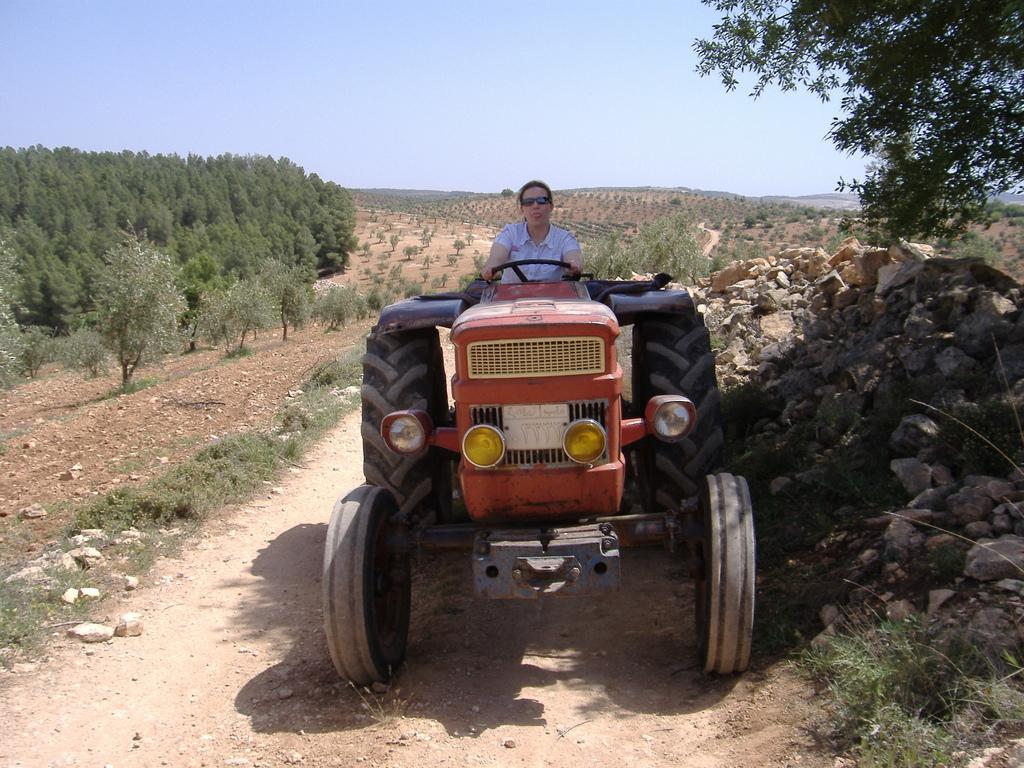Please provide a concise description of this image. In this image I see a person who is sitting on this tractor and I see the path and I see the grass and number of stones. In the background I see number of trees and plants and I see the sky. 